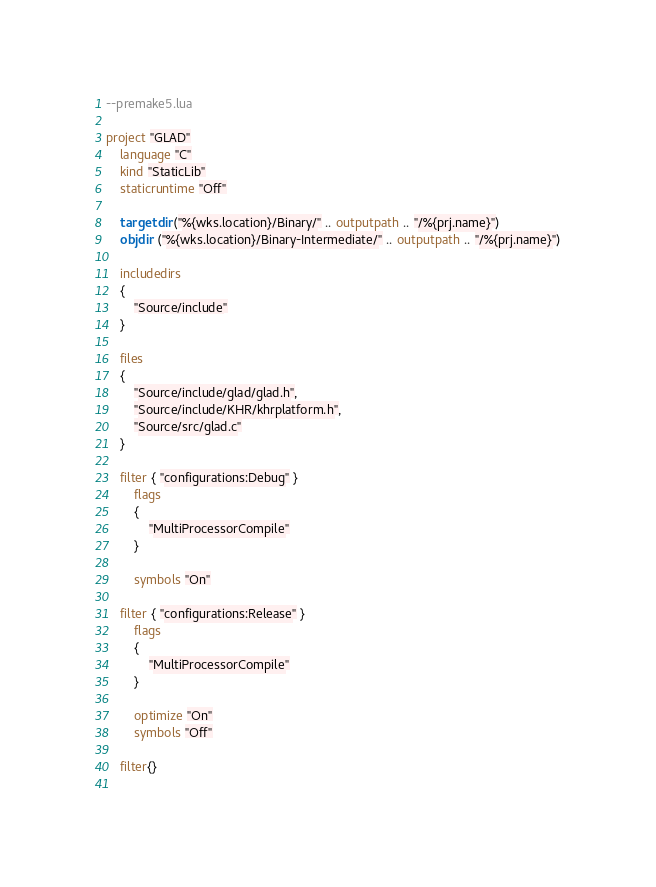Convert code to text. <code><loc_0><loc_0><loc_500><loc_500><_Lua_>--premake5.lua

project "GLAD"
	language "C"
	kind "StaticLib"
	staticruntime "Off"
	
	targetdir ("%{wks.location}/Binary/" .. outputpath .. "/%{prj.name}")
	objdir ("%{wks.location}/Binary-Intermediate/" .. outputpath .. "/%{prj.name}")
	
	includedirs
	{
		"Source/include"
	}
	
	files
	{
		"Source/include/glad/glad.h",
		"Source/include/KHR/khrplatform.h",
		"Source/src/glad.c"
	}
	
	filter { "configurations:Debug" }
		flags
		{
			"MultiProcessorCompile"
		}
		
		symbols "On"
		
	filter { "configurations:Release" }
		flags
		{
			"MultiProcessorCompile"
		}
		
		optimize "On"
		symbols "Off"
		
	filter{}
	</code> 